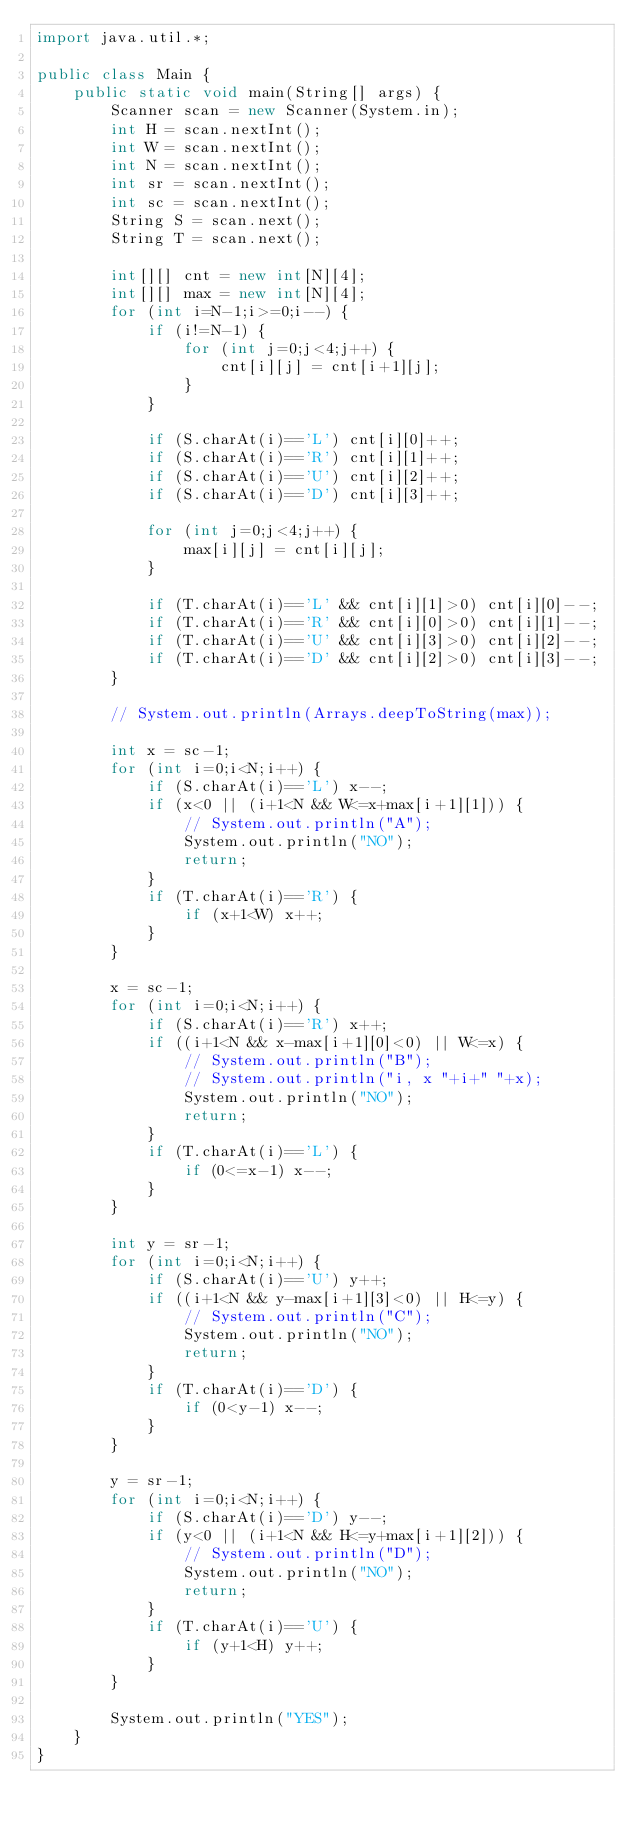Convert code to text. <code><loc_0><loc_0><loc_500><loc_500><_Java_>import java.util.*;

public class Main {
    public static void main(String[] args) {
        Scanner scan = new Scanner(System.in);
        int H = scan.nextInt();
        int W = scan.nextInt();
        int N = scan.nextInt();
        int sr = scan.nextInt();
        int sc = scan.nextInt();
        String S = scan.next();
        String T = scan.next();

        int[][] cnt = new int[N][4];
        int[][] max = new int[N][4];
        for (int i=N-1;i>=0;i--) {
            if (i!=N-1) {
                for (int j=0;j<4;j++) {
                    cnt[i][j] = cnt[i+1][j];
                }
            }

            if (S.charAt(i)=='L') cnt[i][0]++;
            if (S.charAt(i)=='R') cnt[i][1]++;
            if (S.charAt(i)=='U') cnt[i][2]++;
            if (S.charAt(i)=='D') cnt[i][3]++;

            for (int j=0;j<4;j++) {
                max[i][j] = cnt[i][j];
            }

            if (T.charAt(i)=='L' && cnt[i][1]>0) cnt[i][0]--;
            if (T.charAt(i)=='R' && cnt[i][0]>0) cnt[i][1]--;
            if (T.charAt(i)=='U' && cnt[i][3]>0) cnt[i][2]--;
            if (T.charAt(i)=='D' && cnt[i][2]>0) cnt[i][3]--;
        }

        // System.out.println(Arrays.deepToString(max));

        int x = sc-1;
        for (int i=0;i<N;i++) {
            if (S.charAt(i)=='L') x--;
            if (x<0 || (i+1<N && W<=x+max[i+1][1])) {
                // System.out.println("A");
                System.out.println("NO");
                return;
            }
            if (T.charAt(i)=='R') {
                if (x+1<W) x++;
            }
        }

        x = sc-1;
        for (int i=0;i<N;i++) {
            if (S.charAt(i)=='R') x++;
            if ((i+1<N && x-max[i+1][0]<0) || W<=x) {
                // System.out.println("B");
                // System.out.println("i, x "+i+" "+x);
                System.out.println("NO");
                return;
            }
            if (T.charAt(i)=='L') {
                if (0<=x-1) x--;
            }
        }

        int y = sr-1;
        for (int i=0;i<N;i++) {
            if (S.charAt(i)=='U') y++;
            if ((i+1<N && y-max[i+1][3]<0) || H<=y) {
                // System.out.println("C");
                System.out.println("NO");
                return;
            }
            if (T.charAt(i)=='D') {
                if (0<y-1) x--;
            }
        }

        y = sr-1;
        for (int i=0;i<N;i++) {
            if (S.charAt(i)=='D') y--;
            if (y<0 || (i+1<N && H<=y+max[i+1][2])) {
                // System.out.println("D");
                System.out.println("NO");
                return;
            }
            if (T.charAt(i)=='U') {
                if (y+1<H) y++;
            }
        }

        System.out.println("YES");
    }
}
</code> 